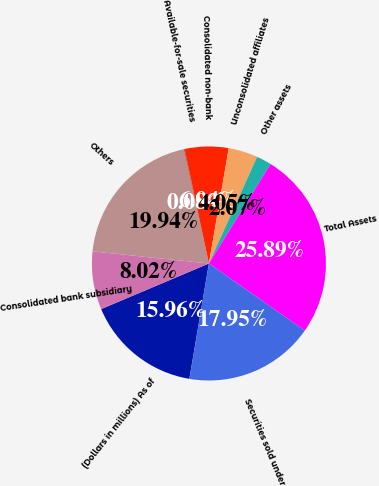Convert chart. <chart><loc_0><loc_0><loc_500><loc_500><pie_chart><fcel>(Dollars in millions) As of<fcel>Consolidated bank subsidiary<fcel>Others<fcel>Available-for-sale securities<fcel>Consolidated non-bank<fcel>Unconsolidated affiliates<fcel>Other assets<fcel>Total Assets<fcel>Securities sold under<nl><fcel>15.96%<fcel>8.02%<fcel>19.94%<fcel>0.08%<fcel>6.04%<fcel>4.05%<fcel>2.07%<fcel>25.89%<fcel>17.95%<nl></chart> 